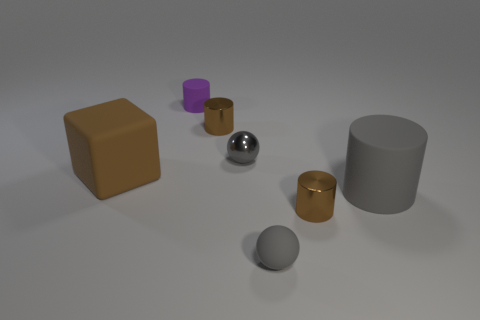Add 1 gray metallic objects. How many objects exist? 8 Subtract all cubes. How many objects are left? 6 Add 7 tiny purple matte things. How many tiny purple matte things exist? 8 Subtract 0 red balls. How many objects are left? 7 Subtract all purple rubber cylinders. Subtract all red blocks. How many objects are left? 6 Add 7 brown cylinders. How many brown cylinders are left? 9 